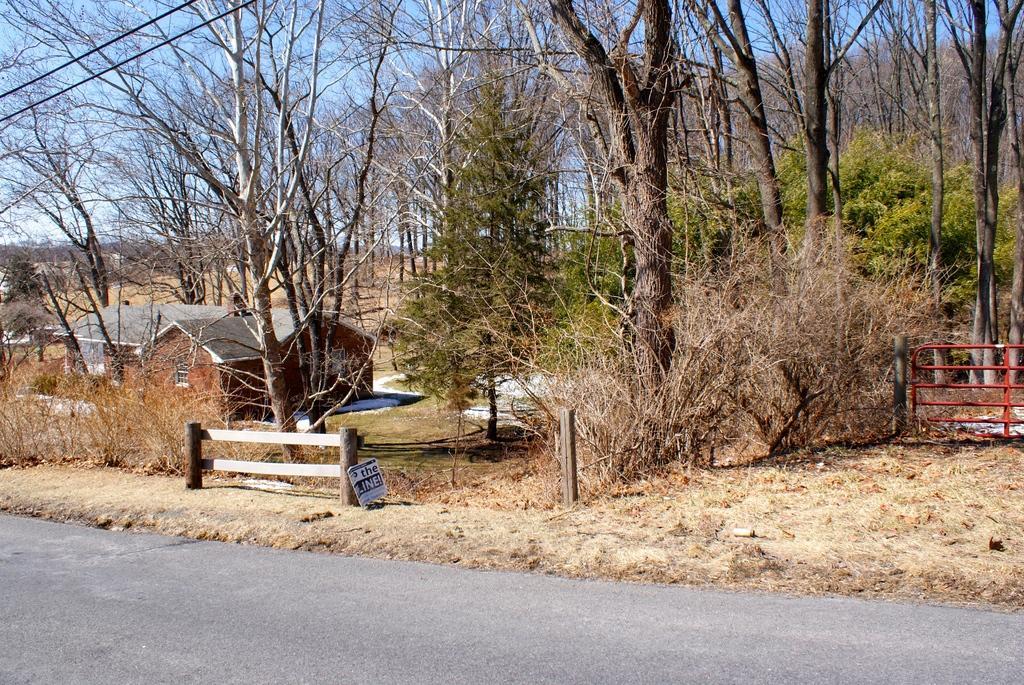Could you give a brief overview of what you see in this image? In this image I can see few houses, fencing, few trees. In the background the sky is in blue color. 